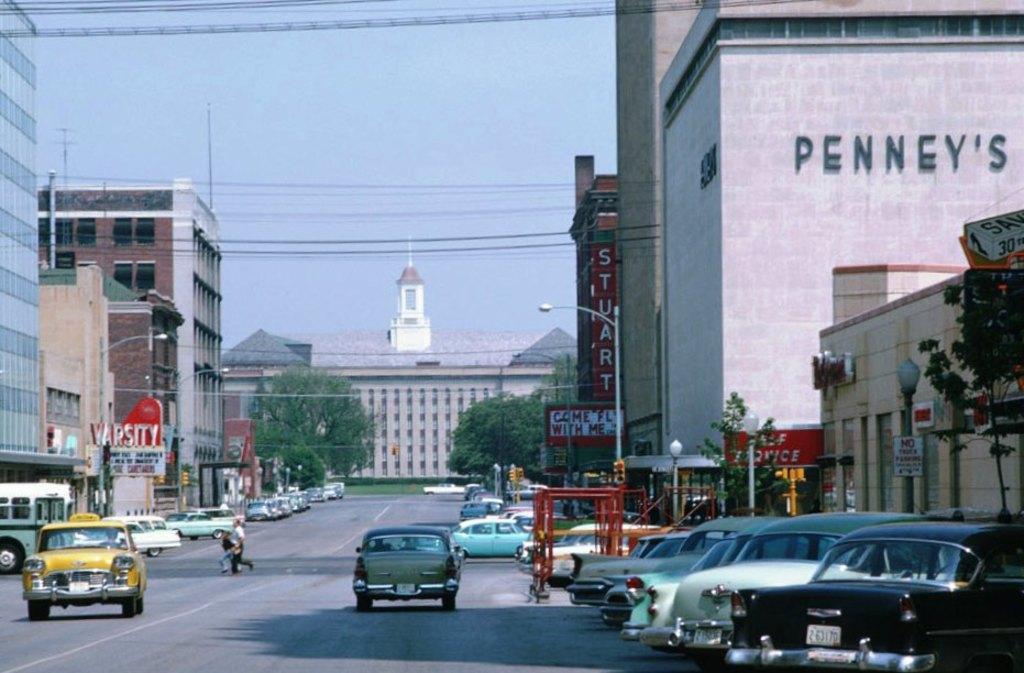<image>
Create a compact narrative representing the image presented. Old cars drive through a city street next to building with the word Penney's on it. 